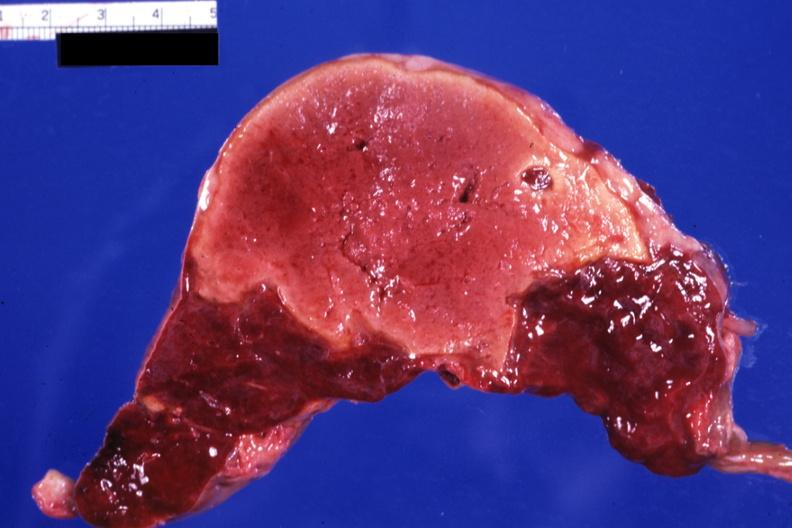what is present?
Answer the question using a single word or phrase. Hematologic 